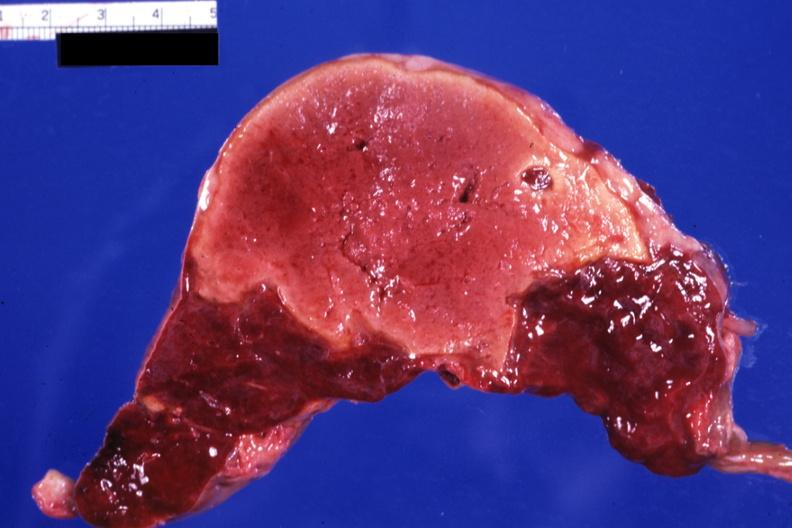what is present?
Answer the question using a single word or phrase. Hematologic 